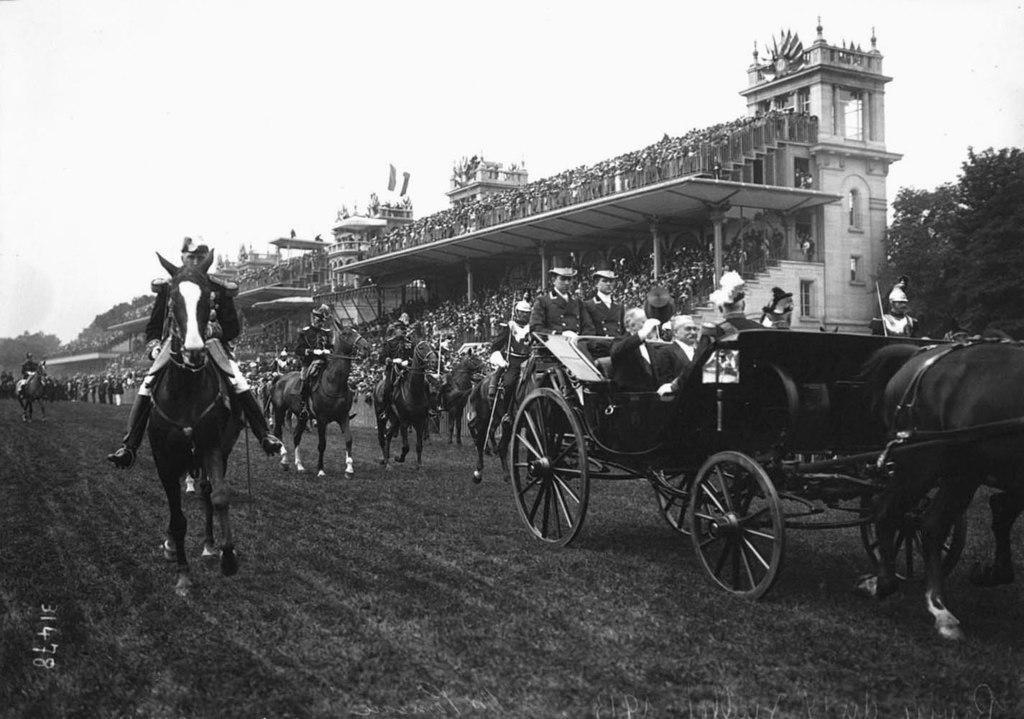Describe this image in one or two sentences. In this picture we can observe some horses. There are some persons on the horses who are riding them. On the right side there is a chariot and a horse. There are some people sitting in the chariot. We can observe some people sitting in the chairs. There is a building. There are some trees. In the background there is a sky. 